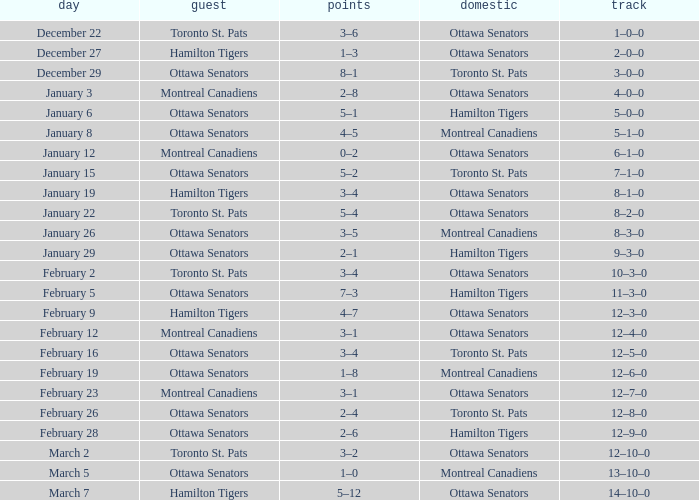What is the score of the game on January 12? 0–2. Would you be able to parse every entry in this table? {'header': ['day', 'guest', 'points', 'domestic', 'track'], 'rows': [['December 22', 'Toronto St. Pats', '3–6', 'Ottawa Senators', '1–0–0'], ['December 27', 'Hamilton Tigers', '1–3', 'Ottawa Senators', '2–0–0'], ['December 29', 'Ottawa Senators', '8–1', 'Toronto St. Pats', '3–0–0'], ['January 3', 'Montreal Canadiens', '2–8', 'Ottawa Senators', '4–0–0'], ['January 6', 'Ottawa Senators', '5–1', 'Hamilton Tigers', '5–0–0'], ['January 8', 'Ottawa Senators', '4–5', 'Montreal Canadiens', '5–1–0'], ['January 12', 'Montreal Canadiens', '0–2', 'Ottawa Senators', '6–1–0'], ['January 15', 'Ottawa Senators', '5–2', 'Toronto St. Pats', '7–1–0'], ['January 19', 'Hamilton Tigers', '3–4', 'Ottawa Senators', '8–1–0'], ['January 22', 'Toronto St. Pats', '5–4', 'Ottawa Senators', '8–2–0'], ['January 26', 'Ottawa Senators', '3–5', 'Montreal Canadiens', '8–3–0'], ['January 29', 'Ottawa Senators', '2–1', 'Hamilton Tigers', '9–3–0'], ['February 2', 'Toronto St. Pats', '3–4', 'Ottawa Senators', '10–3–0'], ['February 5', 'Ottawa Senators', '7–3', 'Hamilton Tigers', '11–3–0'], ['February 9', 'Hamilton Tigers', '4–7', 'Ottawa Senators', '12–3–0'], ['February 12', 'Montreal Canadiens', '3–1', 'Ottawa Senators', '12–4–0'], ['February 16', 'Ottawa Senators', '3–4', 'Toronto St. Pats', '12–5–0'], ['February 19', 'Ottawa Senators', '1–8', 'Montreal Canadiens', '12–6–0'], ['February 23', 'Montreal Canadiens', '3–1', 'Ottawa Senators', '12–7–0'], ['February 26', 'Ottawa Senators', '2–4', 'Toronto St. Pats', '12–8–0'], ['February 28', 'Ottawa Senators', '2–6', 'Hamilton Tigers', '12–9–0'], ['March 2', 'Toronto St. Pats', '3–2', 'Ottawa Senators', '12–10–0'], ['March 5', 'Ottawa Senators', '1–0', 'Montreal Canadiens', '13–10–0'], ['March 7', 'Hamilton Tigers', '5–12', 'Ottawa Senators', '14–10–0']]} 